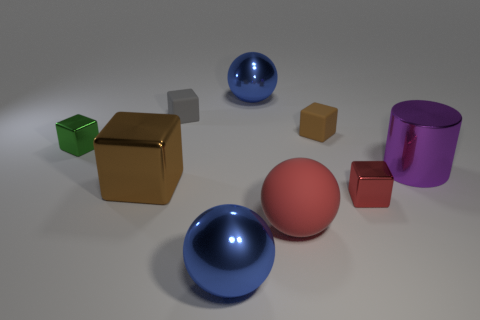Subtract all green metal cubes. How many cubes are left? 4 Subtract all red cubes. How many cubes are left? 4 Subtract all yellow blocks. Subtract all purple spheres. How many blocks are left? 5 Add 1 metal cubes. How many objects exist? 10 Subtract all spheres. How many objects are left? 6 Add 6 big balls. How many big balls exist? 9 Subtract 0 yellow cubes. How many objects are left? 9 Subtract all small gray objects. Subtract all tiny red metallic things. How many objects are left? 7 Add 5 small red shiny things. How many small red shiny things are left? 6 